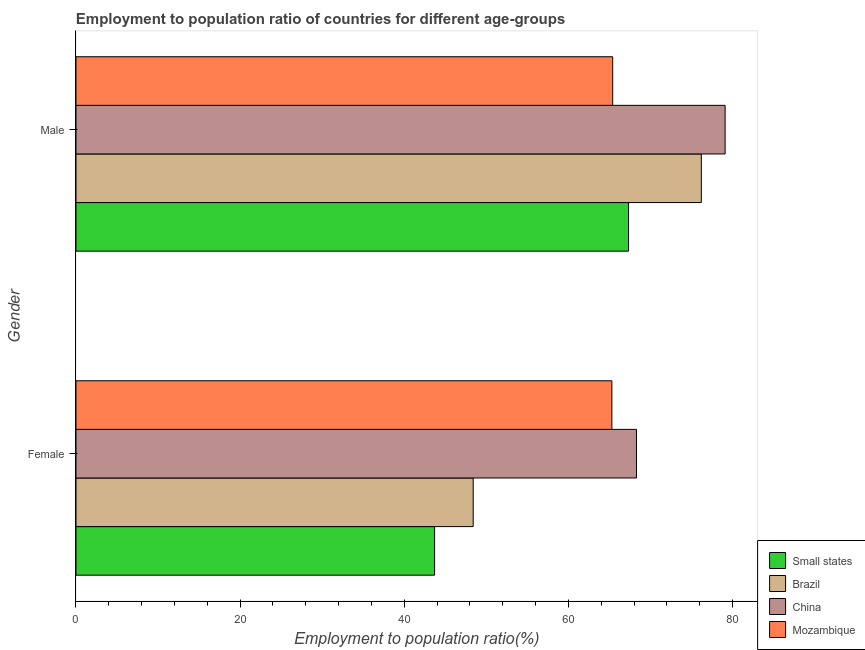How many groups of bars are there?
Your response must be concise. 2. Are the number of bars on each tick of the Y-axis equal?
Offer a terse response. Yes. How many bars are there on the 2nd tick from the top?
Provide a succinct answer. 4. How many bars are there on the 1st tick from the bottom?
Provide a short and direct response. 4. What is the label of the 2nd group of bars from the top?
Keep it short and to the point. Female. What is the employment to population ratio(male) in Brazil?
Ensure brevity in your answer.  76.2. Across all countries, what is the maximum employment to population ratio(female)?
Provide a short and direct response. 68.3. Across all countries, what is the minimum employment to population ratio(male)?
Make the answer very short. 65.4. In which country was the employment to population ratio(female) maximum?
Offer a very short reply. China. In which country was the employment to population ratio(male) minimum?
Provide a succinct answer. Mozambique. What is the total employment to population ratio(female) in the graph?
Your answer should be very brief. 225.7. What is the difference between the employment to population ratio(female) in Small states and that in China?
Offer a very short reply. -24.6. What is the difference between the employment to population ratio(female) in China and the employment to population ratio(male) in Small states?
Provide a short and direct response. 0.97. What is the average employment to population ratio(female) per country?
Provide a short and direct response. 56.42. What is the difference between the employment to population ratio(male) and employment to population ratio(female) in Brazil?
Your answer should be very brief. 27.8. In how many countries, is the employment to population ratio(male) greater than 68 %?
Give a very brief answer. 2. What is the ratio of the employment to population ratio(female) in Small states to that in Brazil?
Provide a short and direct response. 0.9. Is the employment to population ratio(female) in China less than that in Small states?
Make the answer very short. No. In how many countries, is the employment to population ratio(female) greater than the average employment to population ratio(female) taken over all countries?
Keep it short and to the point. 2. What does the 3rd bar from the top in Male represents?
Make the answer very short. Brazil. What does the 1st bar from the bottom in Male represents?
Make the answer very short. Small states. How many bars are there?
Your answer should be very brief. 8. Are all the bars in the graph horizontal?
Provide a succinct answer. Yes. How many countries are there in the graph?
Your answer should be very brief. 4. What is the difference between two consecutive major ticks on the X-axis?
Provide a succinct answer. 20. Does the graph contain any zero values?
Your answer should be very brief. No. Does the graph contain grids?
Ensure brevity in your answer.  No. How many legend labels are there?
Keep it short and to the point. 4. What is the title of the graph?
Ensure brevity in your answer.  Employment to population ratio of countries for different age-groups. Does "Tunisia" appear as one of the legend labels in the graph?
Ensure brevity in your answer.  No. What is the label or title of the X-axis?
Keep it short and to the point. Employment to population ratio(%). What is the label or title of the Y-axis?
Your answer should be compact. Gender. What is the Employment to population ratio(%) in Small states in Female?
Offer a terse response. 43.7. What is the Employment to population ratio(%) of Brazil in Female?
Your response must be concise. 48.4. What is the Employment to population ratio(%) of China in Female?
Your answer should be very brief. 68.3. What is the Employment to population ratio(%) of Mozambique in Female?
Your answer should be very brief. 65.3. What is the Employment to population ratio(%) in Small states in Male?
Your response must be concise. 67.33. What is the Employment to population ratio(%) in Brazil in Male?
Make the answer very short. 76.2. What is the Employment to population ratio(%) in China in Male?
Provide a succinct answer. 79.1. What is the Employment to population ratio(%) in Mozambique in Male?
Your response must be concise. 65.4. Across all Gender, what is the maximum Employment to population ratio(%) of Small states?
Offer a terse response. 67.33. Across all Gender, what is the maximum Employment to population ratio(%) of Brazil?
Provide a succinct answer. 76.2. Across all Gender, what is the maximum Employment to population ratio(%) of China?
Give a very brief answer. 79.1. Across all Gender, what is the maximum Employment to population ratio(%) in Mozambique?
Offer a terse response. 65.4. Across all Gender, what is the minimum Employment to population ratio(%) in Small states?
Your response must be concise. 43.7. Across all Gender, what is the minimum Employment to population ratio(%) of Brazil?
Offer a terse response. 48.4. Across all Gender, what is the minimum Employment to population ratio(%) of China?
Your answer should be very brief. 68.3. Across all Gender, what is the minimum Employment to population ratio(%) of Mozambique?
Ensure brevity in your answer.  65.3. What is the total Employment to population ratio(%) in Small states in the graph?
Ensure brevity in your answer.  111.03. What is the total Employment to population ratio(%) in Brazil in the graph?
Keep it short and to the point. 124.6. What is the total Employment to population ratio(%) of China in the graph?
Offer a very short reply. 147.4. What is the total Employment to population ratio(%) in Mozambique in the graph?
Your response must be concise. 130.7. What is the difference between the Employment to population ratio(%) of Small states in Female and that in Male?
Keep it short and to the point. -23.63. What is the difference between the Employment to population ratio(%) in Brazil in Female and that in Male?
Keep it short and to the point. -27.8. What is the difference between the Employment to population ratio(%) in Small states in Female and the Employment to population ratio(%) in Brazil in Male?
Your answer should be compact. -32.5. What is the difference between the Employment to population ratio(%) of Small states in Female and the Employment to population ratio(%) of China in Male?
Provide a short and direct response. -35.4. What is the difference between the Employment to population ratio(%) in Small states in Female and the Employment to population ratio(%) in Mozambique in Male?
Your answer should be compact. -21.7. What is the difference between the Employment to population ratio(%) of Brazil in Female and the Employment to population ratio(%) of China in Male?
Your answer should be compact. -30.7. What is the average Employment to population ratio(%) of Small states per Gender?
Provide a succinct answer. 55.51. What is the average Employment to population ratio(%) of Brazil per Gender?
Offer a terse response. 62.3. What is the average Employment to population ratio(%) in China per Gender?
Provide a succinct answer. 73.7. What is the average Employment to population ratio(%) in Mozambique per Gender?
Give a very brief answer. 65.35. What is the difference between the Employment to population ratio(%) of Small states and Employment to population ratio(%) of Brazil in Female?
Provide a short and direct response. -4.7. What is the difference between the Employment to population ratio(%) in Small states and Employment to population ratio(%) in China in Female?
Offer a terse response. -24.6. What is the difference between the Employment to population ratio(%) in Small states and Employment to population ratio(%) in Mozambique in Female?
Provide a succinct answer. -21.6. What is the difference between the Employment to population ratio(%) in Brazil and Employment to population ratio(%) in China in Female?
Your answer should be very brief. -19.9. What is the difference between the Employment to population ratio(%) of Brazil and Employment to population ratio(%) of Mozambique in Female?
Offer a very short reply. -16.9. What is the difference between the Employment to population ratio(%) in China and Employment to population ratio(%) in Mozambique in Female?
Provide a succinct answer. 3. What is the difference between the Employment to population ratio(%) in Small states and Employment to population ratio(%) in Brazil in Male?
Make the answer very short. -8.87. What is the difference between the Employment to population ratio(%) of Small states and Employment to population ratio(%) of China in Male?
Offer a very short reply. -11.77. What is the difference between the Employment to population ratio(%) of Small states and Employment to population ratio(%) of Mozambique in Male?
Ensure brevity in your answer.  1.93. What is the difference between the Employment to population ratio(%) in Brazil and Employment to population ratio(%) in China in Male?
Provide a succinct answer. -2.9. What is the difference between the Employment to population ratio(%) of Brazil and Employment to population ratio(%) of Mozambique in Male?
Make the answer very short. 10.8. What is the ratio of the Employment to population ratio(%) in Small states in Female to that in Male?
Ensure brevity in your answer.  0.65. What is the ratio of the Employment to population ratio(%) in Brazil in Female to that in Male?
Give a very brief answer. 0.64. What is the ratio of the Employment to population ratio(%) of China in Female to that in Male?
Provide a succinct answer. 0.86. What is the difference between the highest and the second highest Employment to population ratio(%) of Small states?
Provide a succinct answer. 23.63. What is the difference between the highest and the second highest Employment to population ratio(%) in Brazil?
Provide a short and direct response. 27.8. What is the difference between the highest and the second highest Employment to population ratio(%) of China?
Your answer should be very brief. 10.8. What is the difference between the highest and the second highest Employment to population ratio(%) in Mozambique?
Offer a terse response. 0.1. What is the difference between the highest and the lowest Employment to population ratio(%) in Small states?
Give a very brief answer. 23.63. What is the difference between the highest and the lowest Employment to population ratio(%) in Brazil?
Offer a very short reply. 27.8. What is the difference between the highest and the lowest Employment to population ratio(%) of Mozambique?
Give a very brief answer. 0.1. 